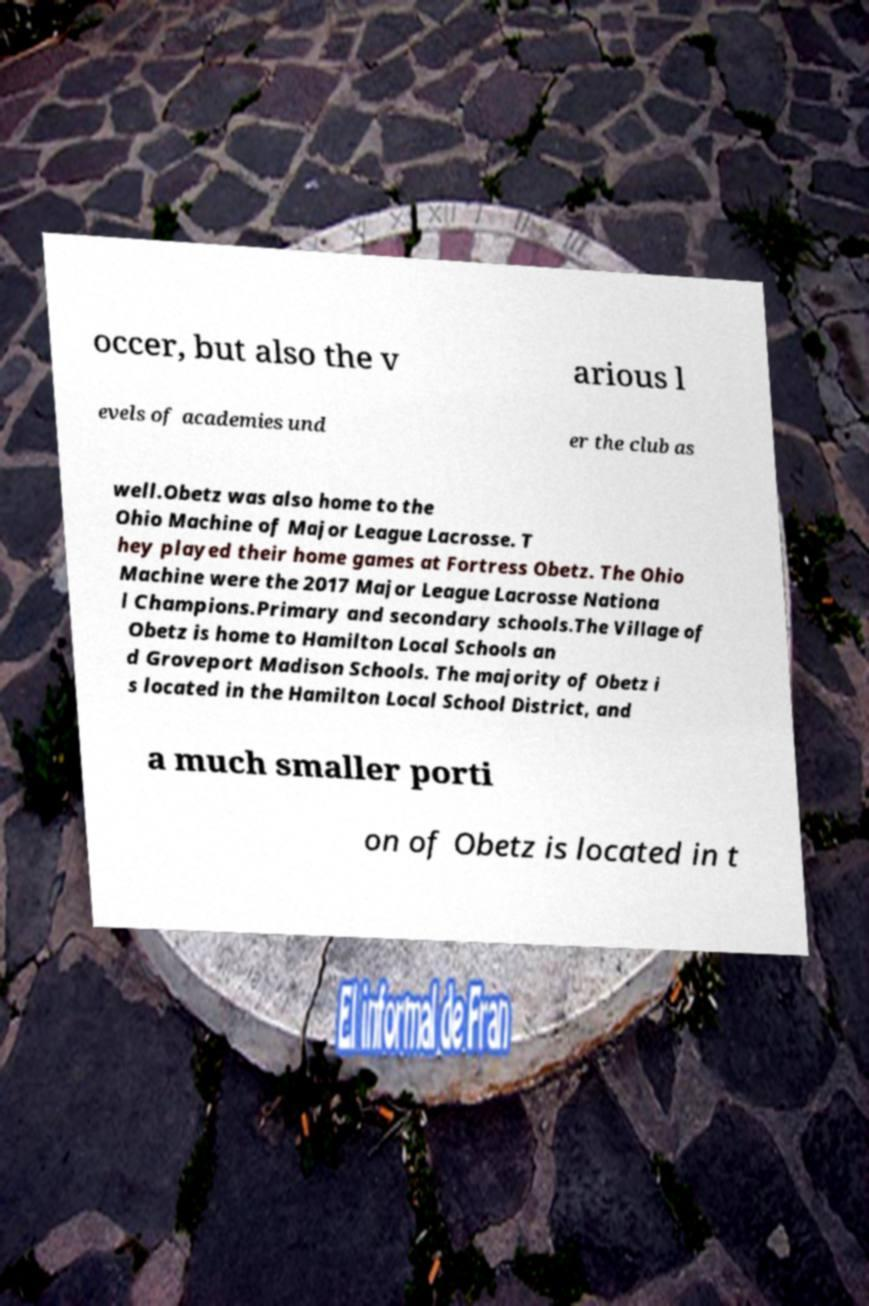Please identify and transcribe the text found in this image. occer, but also the v arious l evels of academies und er the club as well.Obetz was also home to the Ohio Machine of Major League Lacrosse. T hey played their home games at Fortress Obetz. The Ohio Machine were the 2017 Major League Lacrosse Nationa l Champions.Primary and secondary schools.The Village of Obetz is home to Hamilton Local Schools an d Groveport Madison Schools. The majority of Obetz i s located in the Hamilton Local School District, and a much smaller porti on of Obetz is located in t 